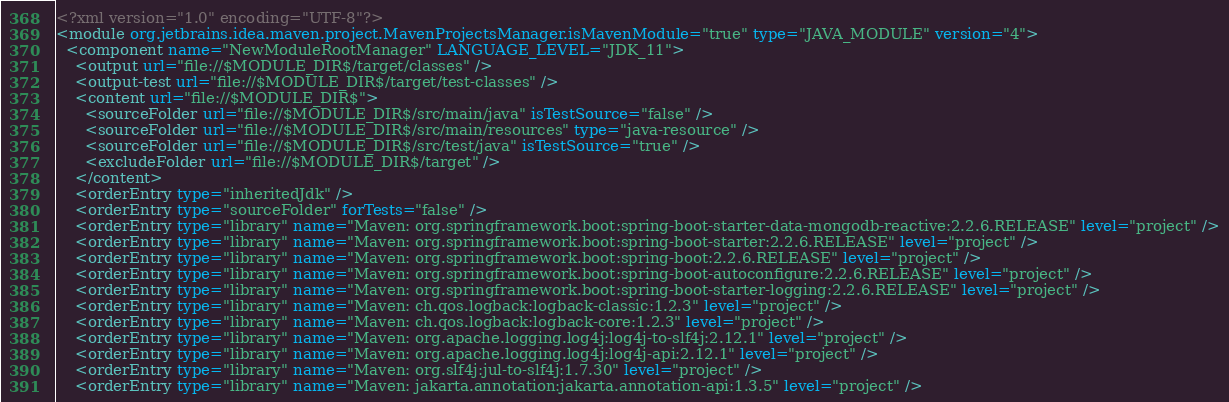<code> <loc_0><loc_0><loc_500><loc_500><_XML_><?xml version="1.0" encoding="UTF-8"?>
<module org.jetbrains.idea.maven.project.MavenProjectsManager.isMavenModule="true" type="JAVA_MODULE" version="4">
  <component name="NewModuleRootManager" LANGUAGE_LEVEL="JDK_11">
    <output url="file://$MODULE_DIR$/target/classes" />
    <output-test url="file://$MODULE_DIR$/target/test-classes" />
    <content url="file://$MODULE_DIR$">
      <sourceFolder url="file://$MODULE_DIR$/src/main/java" isTestSource="false" />
      <sourceFolder url="file://$MODULE_DIR$/src/main/resources" type="java-resource" />
      <sourceFolder url="file://$MODULE_DIR$/src/test/java" isTestSource="true" />
      <excludeFolder url="file://$MODULE_DIR$/target" />
    </content>
    <orderEntry type="inheritedJdk" />
    <orderEntry type="sourceFolder" forTests="false" />
    <orderEntry type="library" name="Maven: org.springframework.boot:spring-boot-starter-data-mongodb-reactive:2.2.6.RELEASE" level="project" />
    <orderEntry type="library" name="Maven: org.springframework.boot:spring-boot-starter:2.2.6.RELEASE" level="project" />
    <orderEntry type="library" name="Maven: org.springframework.boot:spring-boot:2.2.6.RELEASE" level="project" />
    <orderEntry type="library" name="Maven: org.springframework.boot:spring-boot-autoconfigure:2.2.6.RELEASE" level="project" />
    <orderEntry type="library" name="Maven: org.springframework.boot:spring-boot-starter-logging:2.2.6.RELEASE" level="project" />
    <orderEntry type="library" name="Maven: ch.qos.logback:logback-classic:1.2.3" level="project" />
    <orderEntry type="library" name="Maven: ch.qos.logback:logback-core:1.2.3" level="project" />
    <orderEntry type="library" name="Maven: org.apache.logging.log4j:log4j-to-slf4j:2.12.1" level="project" />
    <orderEntry type="library" name="Maven: org.apache.logging.log4j:log4j-api:2.12.1" level="project" />
    <orderEntry type="library" name="Maven: org.slf4j:jul-to-slf4j:1.7.30" level="project" />
    <orderEntry type="library" name="Maven: jakarta.annotation:jakarta.annotation-api:1.3.5" level="project" /></code> 